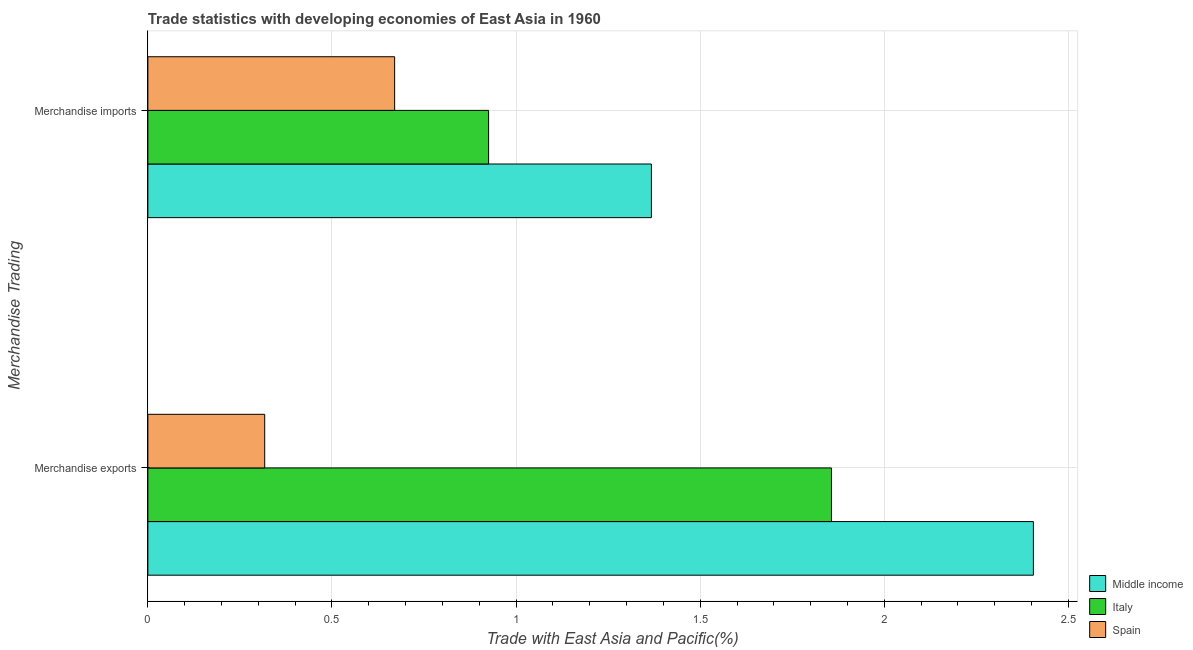How many different coloured bars are there?
Your answer should be compact. 3. How many groups of bars are there?
Provide a succinct answer. 2. Are the number of bars per tick equal to the number of legend labels?
Provide a short and direct response. Yes. Are the number of bars on each tick of the Y-axis equal?
Offer a terse response. Yes. How many bars are there on the 2nd tick from the bottom?
Ensure brevity in your answer.  3. What is the merchandise imports in Middle income?
Ensure brevity in your answer.  1.37. Across all countries, what is the maximum merchandise exports?
Ensure brevity in your answer.  2.4. Across all countries, what is the minimum merchandise imports?
Ensure brevity in your answer.  0.67. In which country was the merchandise imports maximum?
Provide a short and direct response. Middle income. What is the total merchandise imports in the graph?
Offer a very short reply. 2.96. What is the difference between the merchandise exports in Middle income and that in Spain?
Your answer should be very brief. 2.09. What is the difference between the merchandise exports in Spain and the merchandise imports in Italy?
Provide a succinct answer. -0.61. What is the average merchandise imports per country?
Give a very brief answer. 0.99. What is the difference between the merchandise imports and merchandise exports in Spain?
Your answer should be very brief. 0.35. What is the ratio of the merchandise exports in Spain to that in Italy?
Your answer should be compact. 0.17. How many bars are there?
Ensure brevity in your answer.  6. Are the values on the major ticks of X-axis written in scientific E-notation?
Offer a terse response. No. Does the graph contain any zero values?
Offer a very short reply. No. Where does the legend appear in the graph?
Your response must be concise. Bottom right. How many legend labels are there?
Offer a very short reply. 3. How are the legend labels stacked?
Provide a short and direct response. Vertical. What is the title of the graph?
Your answer should be very brief. Trade statistics with developing economies of East Asia in 1960. Does "Benin" appear as one of the legend labels in the graph?
Make the answer very short. No. What is the label or title of the X-axis?
Your answer should be very brief. Trade with East Asia and Pacific(%). What is the label or title of the Y-axis?
Provide a short and direct response. Merchandise Trading. What is the Trade with East Asia and Pacific(%) of Middle income in Merchandise exports?
Your response must be concise. 2.4. What is the Trade with East Asia and Pacific(%) in Italy in Merchandise exports?
Give a very brief answer. 1.86. What is the Trade with East Asia and Pacific(%) in Spain in Merchandise exports?
Your answer should be very brief. 0.32. What is the Trade with East Asia and Pacific(%) in Middle income in Merchandise imports?
Offer a very short reply. 1.37. What is the Trade with East Asia and Pacific(%) of Italy in Merchandise imports?
Offer a very short reply. 0.93. What is the Trade with East Asia and Pacific(%) in Spain in Merchandise imports?
Provide a short and direct response. 0.67. Across all Merchandise Trading, what is the maximum Trade with East Asia and Pacific(%) in Middle income?
Give a very brief answer. 2.4. Across all Merchandise Trading, what is the maximum Trade with East Asia and Pacific(%) of Italy?
Make the answer very short. 1.86. Across all Merchandise Trading, what is the maximum Trade with East Asia and Pacific(%) of Spain?
Keep it short and to the point. 0.67. Across all Merchandise Trading, what is the minimum Trade with East Asia and Pacific(%) in Middle income?
Your answer should be compact. 1.37. Across all Merchandise Trading, what is the minimum Trade with East Asia and Pacific(%) of Italy?
Your answer should be very brief. 0.93. Across all Merchandise Trading, what is the minimum Trade with East Asia and Pacific(%) in Spain?
Make the answer very short. 0.32. What is the total Trade with East Asia and Pacific(%) in Middle income in the graph?
Your answer should be compact. 3.77. What is the total Trade with East Asia and Pacific(%) in Italy in the graph?
Offer a terse response. 2.78. What is the total Trade with East Asia and Pacific(%) in Spain in the graph?
Keep it short and to the point. 0.99. What is the difference between the Trade with East Asia and Pacific(%) in Middle income in Merchandise exports and that in Merchandise imports?
Provide a short and direct response. 1.04. What is the difference between the Trade with East Asia and Pacific(%) in Italy in Merchandise exports and that in Merchandise imports?
Ensure brevity in your answer.  0.93. What is the difference between the Trade with East Asia and Pacific(%) in Spain in Merchandise exports and that in Merchandise imports?
Your answer should be compact. -0.35. What is the difference between the Trade with East Asia and Pacific(%) in Middle income in Merchandise exports and the Trade with East Asia and Pacific(%) in Italy in Merchandise imports?
Make the answer very short. 1.48. What is the difference between the Trade with East Asia and Pacific(%) of Middle income in Merchandise exports and the Trade with East Asia and Pacific(%) of Spain in Merchandise imports?
Offer a terse response. 1.73. What is the difference between the Trade with East Asia and Pacific(%) of Italy in Merchandise exports and the Trade with East Asia and Pacific(%) of Spain in Merchandise imports?
Ensure brevity in your answer.  1.19. What is the average Trade with East Asia and Pacific(%) of Middle income per Merchandise Trading?
Your answer should be compact. 1.89. What is the average Trade with East Asia and Pacific(%) in Italy per Merchandise Trading?
Give a very brief answer. 1.39. What is the average Trade with East Asia and Pacific(%) of Spain per Merchandise Trading?
Keep it short and to the point. 0.49. What is the difference between the Trade with East Asia and Pacific(%) in Middle income and Trade with East Asia and Pacific(%) in Italy in Merchandise exports?
Provide a short and direct response. 0.55. What is the difference between the Trade with East Asia and Pacific(%) of Middle income and Trade with East Asia and Pacific(%) of Spain in Merchandise exports?
Your answer should be compact. 2.09. What is the difference between the Trade with East Asia and Pacific(%) in Italy and Trade with East Asia and Pacific(%) in Spain in Merchandise exports?
Your response must be concise. 1.54. What is the difference between the Trade with East Asia and Pacific(%) of Middle income and Trade with East Asia and Pacific(%) of Italy in Merchandise imports?
Offer a terse response. 0.44. What is the difference between the Trade with East Asia and Pacific(%) of Middle income and Trade with East Asia and Pacific(%) of Spain in Merchandise imports?
Offer a terse response. 0.7. What is the difference between the Trade with East Asia and Pacific(%) of Italy and Trade with East Asia and Pacific(%) of Spain in Merchandise imports?
Your answer should be very brief. 0.26. What is the ratio of the Trade with East Asia and Pacific(%) in Middle income in Merchandise exports to that in Merchandise imports?
Make the answer very short. 1.76. What is the ratio of the Trade with East Asia and Pacific(%) in Italy in Merchandise exports to that in Merchandise imports?
Your answer should be very brief. 2.01. What is the ratio of the Trade with East Asia and Pacific(%) of Spain in Merchandise exports to that in Merchandise imports?
Offer a very short reply. 0.47. What is the difference between the highest and the second highest Trade with East Asia and Pacific(%) of Middle income?
Your response must be concise. 1.04. What is the difference between the highest and the second highest Trade with East Asia and Pacific(%) in Italy?
Keep it short and to the point. 0.93. What is the difference between the highest and the second highest Trade with East Asia and Pacific(%) of Spain?
Keep it short and to the point. 0.35. What is the difference between the highest and the lowest Trade with East Asia and Pacific(%) of Middle income?
Give a very brief answer. 1.04. What is the difference between the highest and the lowest Trade with East Asia and Pacific(%) in Italy?
Your answer should be compact. 0.93. What is the difference between the highest and the lowest Trade with East Asia and Pacific(%) in Spain?
Give a very brief answer. 0.35. 